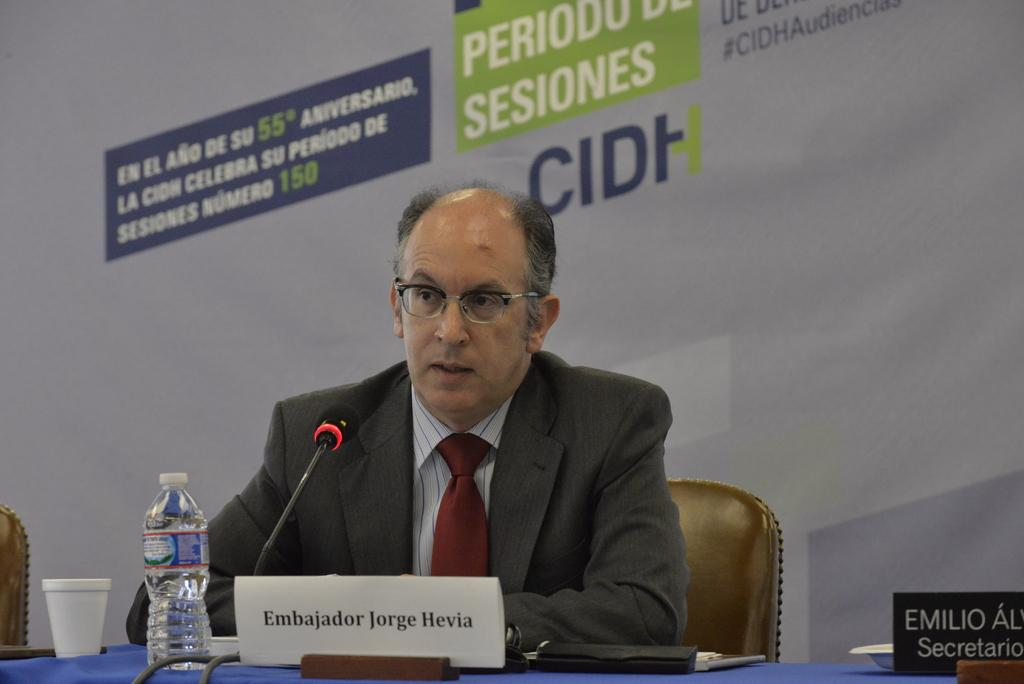What is the man in the image doing? The man is sitting on a chair in the image. What is in front of the man? There is a table in front of the man. What can be seen on the table? There is a microphone and bottles on the table. Are there any other objects on the table? Yes, there are other objects on the table. What type of mine is visible in the image? There is no mine present in the image. 